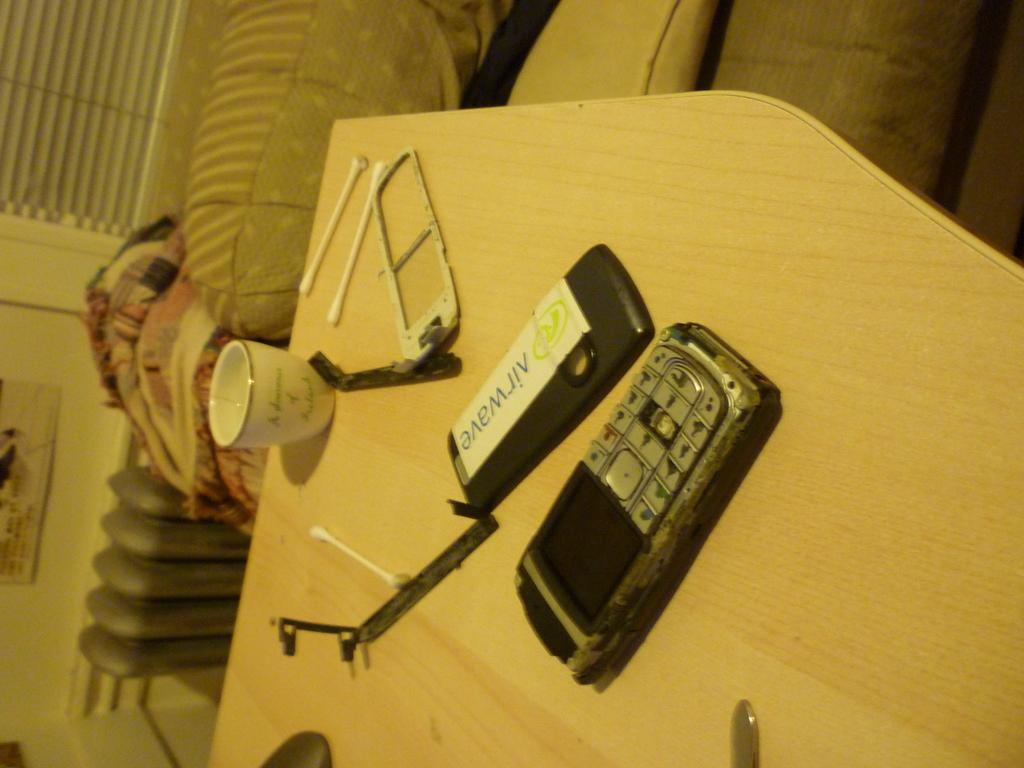<image>
Render a clear and concise summary of the photo. A phone has been taken apart on a wooden table and the back of the phone has a sticker that says airwave on it. 